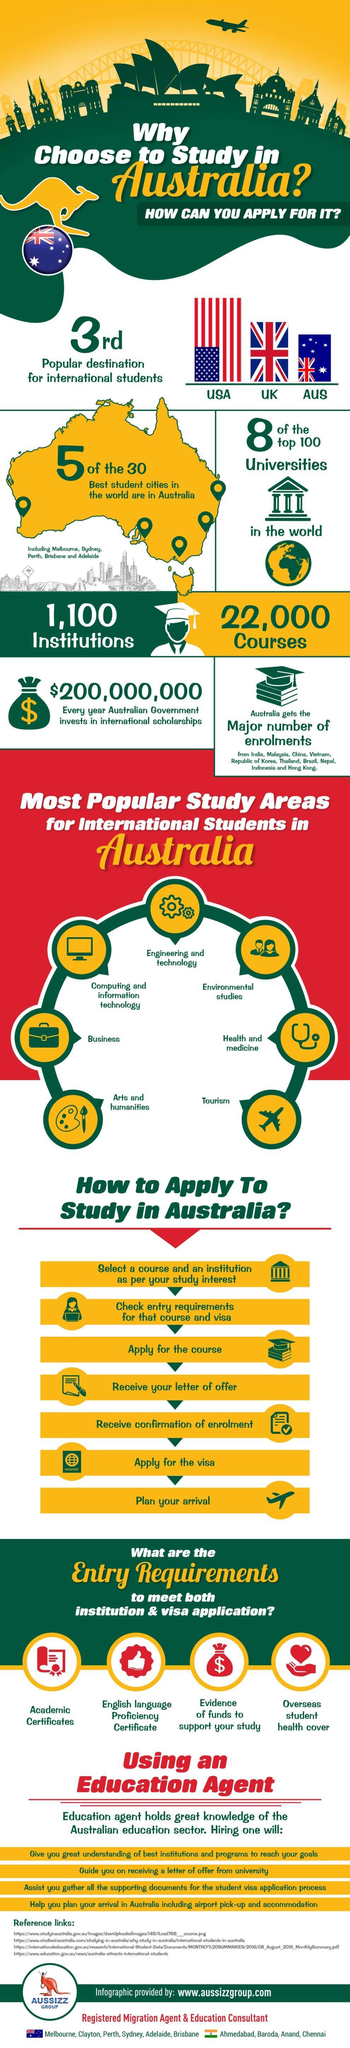How many steps to apply to study in Australia?
Answer the question with a short phrase. 7 What is the number of institutions? 1,100 Which is the first popular destination for international students? USA How many popular study areas for international students in Australia? 7 Which is the second popular destination for international students? UK 